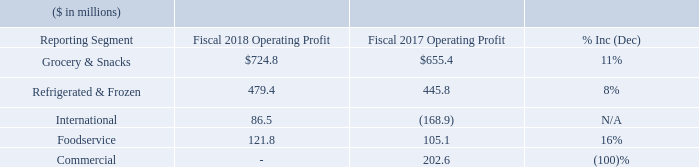Segment Operating Profit (Earnings before general corporate expenses, pension and postretirement non-service income, interest expense, net, income taxes, and equity method investment earnings)
Grocery & Snacks operating profit for fiscal 2018 was $724.8 million, an increase of $69.4 million, or 11%, compared to fiscal 2017. Gross profits were $21.9 million lower in fiscal 2018 than in fiscal 2017. The lower gross profit was driven by investments with retailers (i.e., trade spending reflected as a reduction of net sales), as well as higher input costs and transportation expenses, partially offset by supply chain realized productivity. The Frontera acquisition, Thanasi acquisition, and the acquisition of Angie's Artisan Treats, LLC, which occurred in September 2016, April 2017, and October 2017, respectively, contributed $47.4 million to Grocery & Snacks gross profit during fiscal 2018 through the one-year anniversaries of the acquisitions (if reached). Advertising and promotion expenses for fiscal 2018 decreased by $19.5 million compared to fiscal 2017. Operating profit of the Grocery & Snacks segment was impacted by charges totaling $4.0 million in fiscal 2018 for the impairment of our HK Anderson® , Red Fork® , and Salpica® brand assets and $68.3 million in fiscal 2017 primarily for the impairment of our Chef Boyardee® brand asset. Grocery & Snacks also incurred $11.4 million of expenses in fiscal 2018 related to acquisitions and divestitures, charges of $31.4 million in fiscal 2017 related to the pending divestiture of the Wesson® oil business, and charges of $14.1 million and $23.6 million in connection with our restructuring plans in fiscal 2018 and 2017, respectively.
Refrigerated & Frozen operating profit for fiscal 2018 was $479.4 million, an increase of $33.6 million, or 8%, compared to fiscal 2017. Gross profits were $3.6 million lower in fiscal 2018 than in fiscal 2017, driven by continuing increases in input costs and transportation inflation as well as investments to drive distribution, enhanced shelf presence, and trial, partially offset by increased sales volumes and supply chain realized productivity. The acquisition of the Sandwich Bros. of Wisconsin® business contributed $4.6 million to gross profit in the segment during fiscal 2018. Advertising and promotion expenses for fiscal 2018 decreased by $23.4 million compared to fiscal 2017. Operating profit of the Refrigerated & Frozen segment was impacted by charges totaling approximately $7.7 million in fiscal 2017 related to a product recall, as well as charges of $0.1 million and $6.2 million in connection with our restructuring plans in fiscal 2018 and 2017, respectively.
International operating profit for fiscal 2018 was $86.5 million, compared to an operating loss of $168.9 million for fiscal 2017. The operating loss in fiscal 2017 includes charges totaling $235.9 million for the impairment of goodwill and an intangible brand asset in our Canadian and Mexican operations. Gross profits were $18.6 million higher in fiscal 2018 than in fiscal 2017, as a result of improved price/mix, the favorable impact of foreign exchange, and the planned discontinuations of certain 33 lower-performing products. Operating profit of the International segment was impacted by charges of $1.5 million and $0.9 million in connection with our restructuring plans, in fiscal 2018 and 2017, respectively
Foodservice operating profit for fiscal 2018 was $121.8 million, an increase of $16.7 million, or 16%, compared to fiscal 2017. Gross profits were $13.9 million higher in fiscal 2018 than in fiscal 2017, primarily reflecting the impact of inflation-driven increases in pricing and supply chain realized productivity, partially offset by lower sales volumes and increased input costs. Operating profit of the Foodservice segment was impacted by charges of $1.8 million in fiscal 2017 in connection with our restructuring plans.
Commercial operating profit was $202.6 million in fiscal 2017. The Company sold the Spicetec and JM Swank businesses in the first quarter of fiscal 2017, recognizing pre-tax gains totaling $197.4 million. The Spicetec and JM Swank businesses comprise the entire Commercial segment following the presentation of Lamb Weston as discontinued operations. There are no further operations in the Commercial segment.
What was the expense incurred by Grocery & Snacks related to acquisitions and divestitures in the fiscal year 2018? $11.4 million. How much expense was incurred by Refrigerated & Frozen in the company’s restructuring plans in fiscal 2017 and 2018, respectively? $6.2 million, $0.1 million. What was the operating profit in the Foodservice segment in 2017 and 2018, respectively?
Answer scale should be: million. 105.1, 121.8. What is the total operating profit of all segments in 2018?
Answer scale should be: million. 724.8+479.4+86.5+121.8 
Answer: 1412.5. What is the ratio of Grocery & Snacks’ operating profit to its expense in restructuring plans for the fiscal year 2018? 724.8/14.1 
Answer: 51.4. What is the percentage change in total operating profit in 2018 compared to 2017?
Answer scale should be: percent. ((724.8+479.4+86.5+121.8)-(655.4+445.8-168.9+105.1+202.6))/(655.4+445.8-168.9+105.1+202.6) 
Answer: 13.91. 